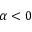<formula> <loc_0><loc_0><loc_500><loc_500>\alpha < 0</formula> 